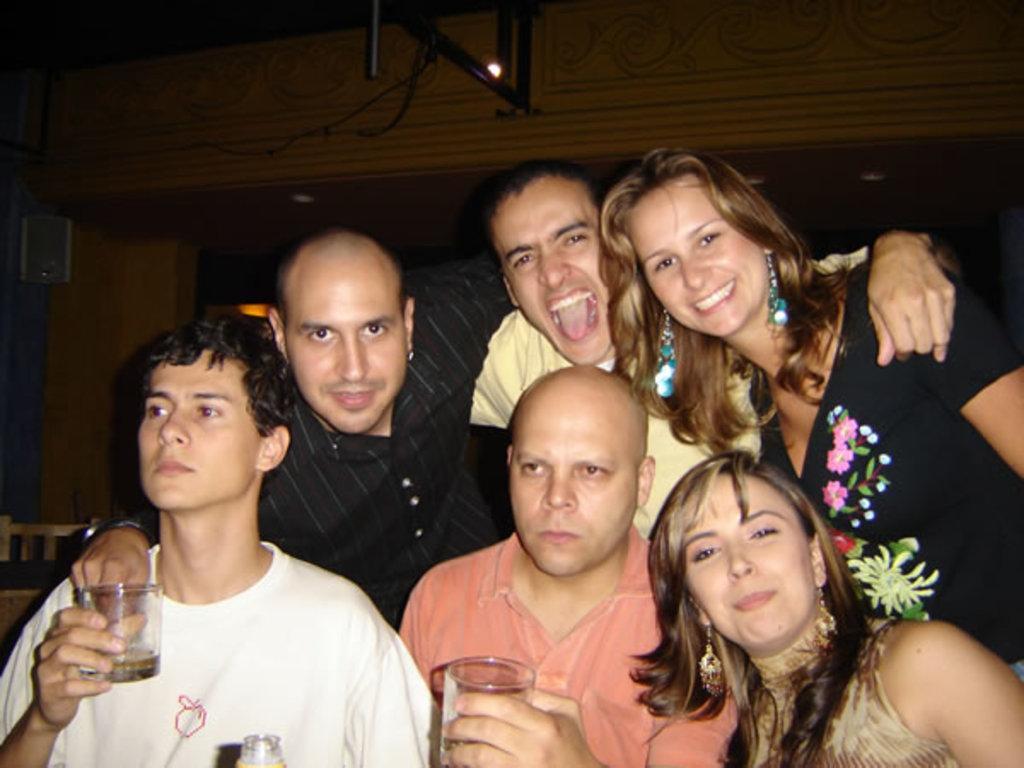How would you summarize this image in a sentence or two? This image consists of many people. It is clicked in a room. In the front, the two men are holding glasses. In the background, there is a wall along with a stand. 